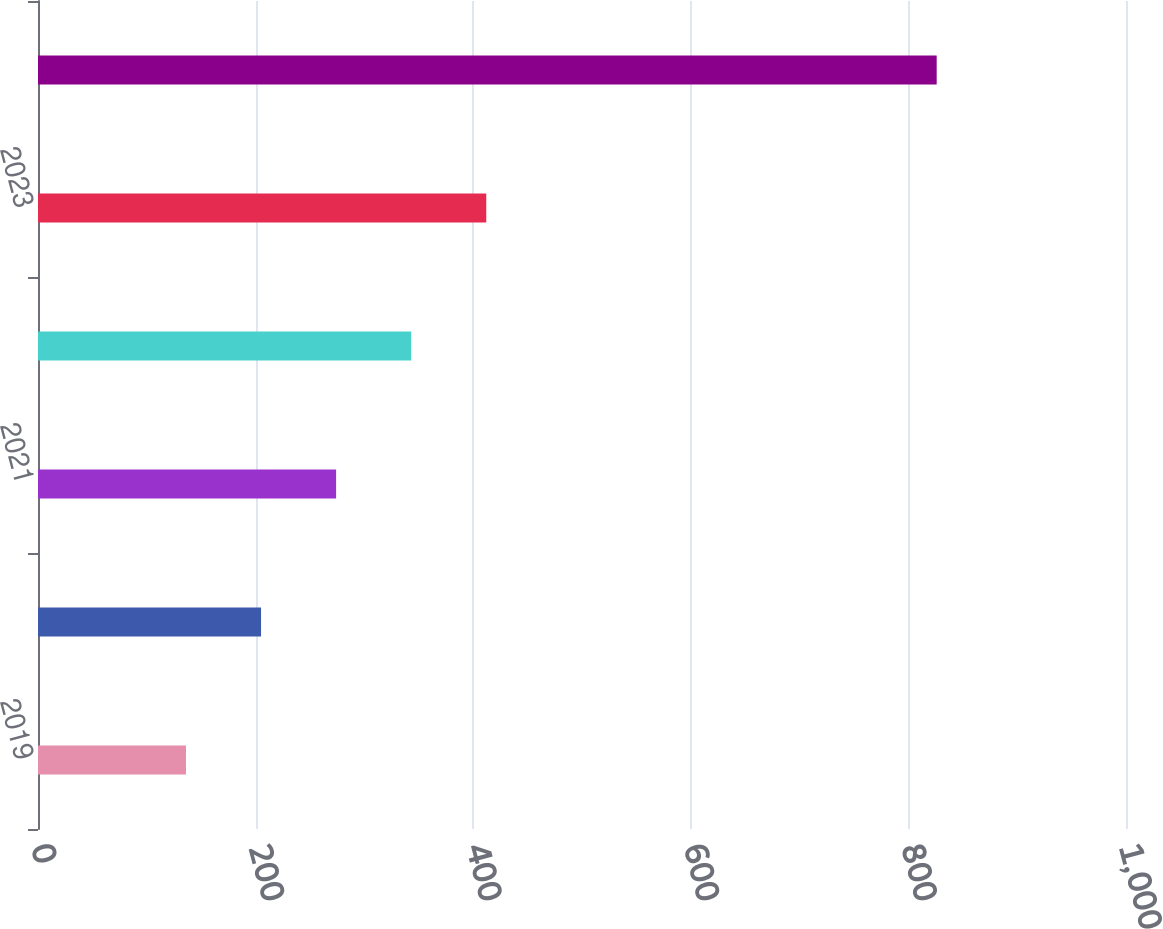Convert chart. <chart><loc_0><loc_0><loc_500><loc_500><bar_chart><fcel>2019<fcel>2020<fcel>2021<fcel>2022<fcel>2023<fcel>2024 to 2028<nl><fcel>136<fcel>205<fcel>274<fcel>343<fcel>412<fcel>826<nl></chart> 